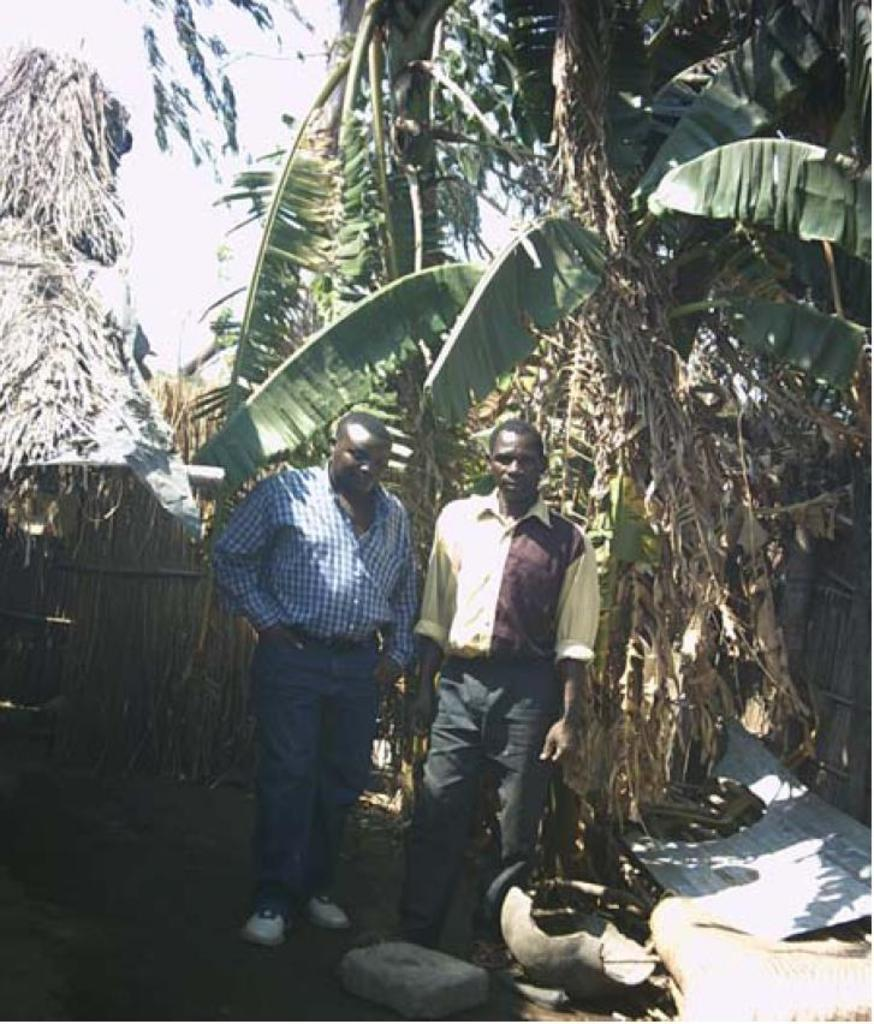How many men are present in the image? There are two men standing on the road in the image. What can be seen in the background of the image? There are trees and rocks in the background of the image. Is there any evidence of damage or destruction in the image? Yes, there is a broken pot in the background of the image. What type of bulb is hanging from the tree in the image? There is no bulb present in the image; it only features two men standing on the road, trees, rocks, and a broken pot in the background. 